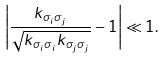Convert formula to latex. <formula><loc_0><loc_0><loc_500><loc_500>\left | \frac { k _ { \sigma _ { i } \sigma _ { j } } } { \sqrt { k _ { \sigma _ { i } \sigma _ { i } } k _ { \sigma _ { j } \sigma _ { j } } } } - 1 \right | \ll 1 .</formula> 